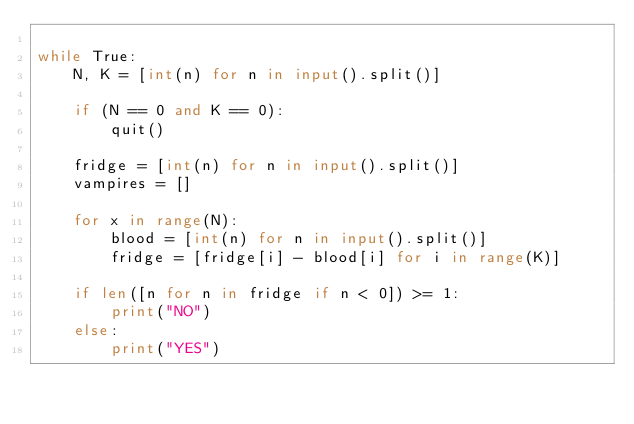<code> <loc_0><loc_0><loc_500><loc_500><_Python_>
while True:
    N, K = [int(n) for n in input().split()]

    if (N == 0 and K == 0):
        quit()

    fridge = [int(n) for n in input().split()]
    vampires = []

    for x in range(N):
        blood = [int(n) for n in input().split()]
        fridge = [fridge[i] - blood[i] for i in range(K)]

    if len([n for n in fridge if n < 0]) >= 1:
        print("NO")
    else:
        print("YES")</code> 